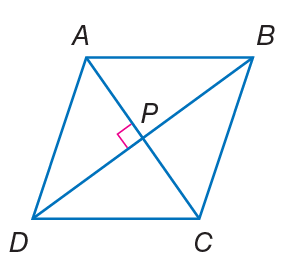Answer the mathemtical geometry problem and directly provide the correct option letter.
Question: Quadrilateral A B C D is a rhombus. If m \angle B C D = 54, find m \angle B A C.
Choices: A: 13 B: 27 C: 50 D: 90 B 